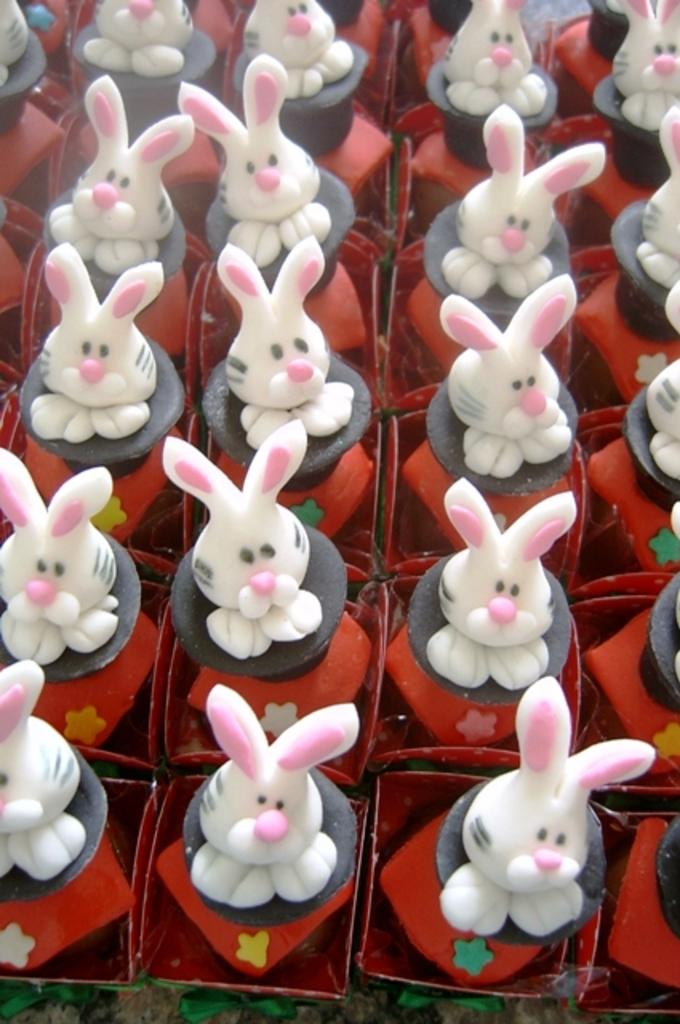What type of toys are present in the image? There are bunny toys in the image. What color are the borders of the image? The borders of the image are white in color. What time does the clock show in the image? There is no clock present in the image, so it is not possible to determine the time. 